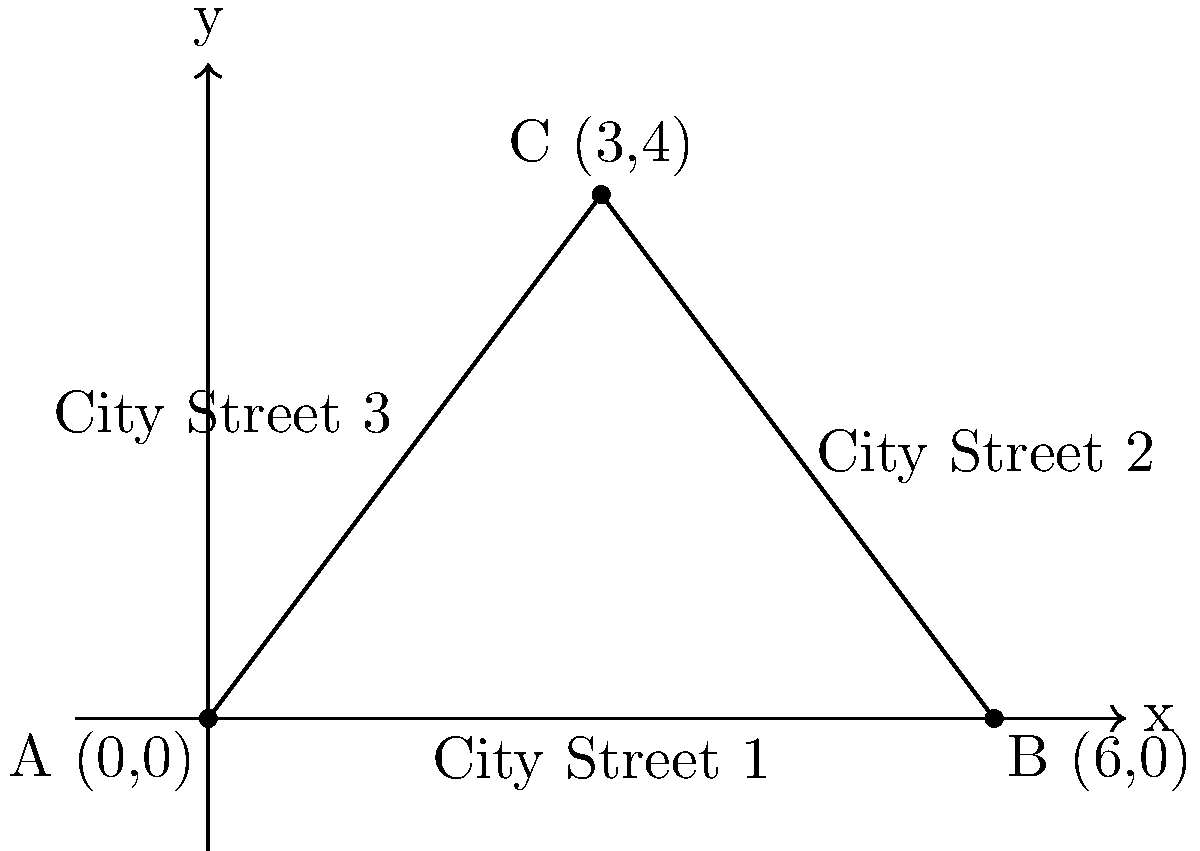In a bustling modern city, a triangular park is formed by the intersection of three streets, represented by the points A(0,0), B(6,0), and C(3,4) on a coordinate plane. As an architecture critic concerned with urban aesthetics, calculate the area of this park. How might the size and shape of this green space contribute to the visual appeal of the surrounding cityscape, especially in contrast to the presence of vintage cars on nearby streets? To calculate the area of the triangular park, we'll use the formula for the area of a triangle given the coordinates of its vertices:

Area = $\frac{1}{2}|x_1(y_2 - y_3) + x_2(y_3 - y_1) + x_3(y_1 - y_2)|$

Where $(x_1, y_1)$, $(x_2, y_2)$, and $(x_3, y_3)$ are the coordinates of the three vertices.

Given:
A(0,0), B(6,0), C(3,4)

Step 1: Substitute the coordinates into the formula:
Area = $\frac{1}{2}|0(0 - 4) + 6(4 - 0) + 3(0 - 0)|$

Step 2: Simplify:
Area = $\frac{1}{2}|0 + 24 + 0|$

Step 3: Calculate:
Area = $\frac{1}{2}(24) = 12$ square units

Therefore, the area of the triangular park is 12 square units.

From an architectural perspective, this triangular park creates an open green space that breaks up the rigid geometry of city streets. Its size and shape provide a visual counterpoint to the linear structure of the surrounding buildings and roads, enhancing the overall aesthetics of the urban landscape. Unlike vintage cars, which may be seen as anachronistic elements in a modern cityscape, this park contributes to the city's livability and visual appeal by offering a natural, organic form amidst the urban environment.
Answer: 12 square units 